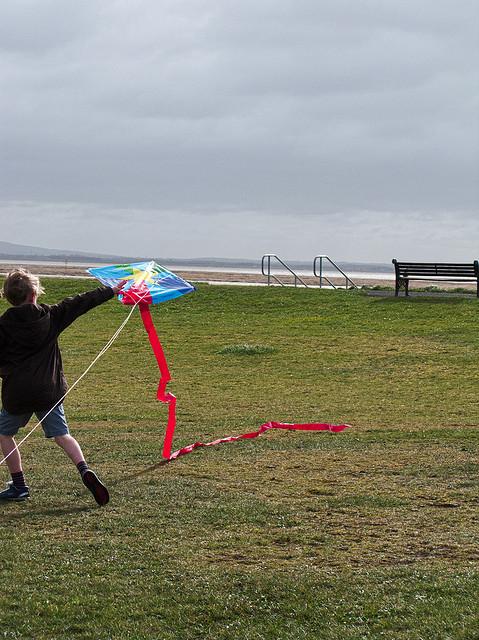Is the kite flying?
Short answer required. No. What is in the background of the picture?
Quick response, please. Bench. What is the boy in black holding?
Short answer required. Kite. Based on the directions and length of the cast shadows, approximately what time of day is it?
Be succinct. Noon. Is the weather sunny?
Give a very brief answer. No. Did the man just steal the boy's kite?
Write a very short answer. No. What is the person playing with?
Answer briefly. Kite. 